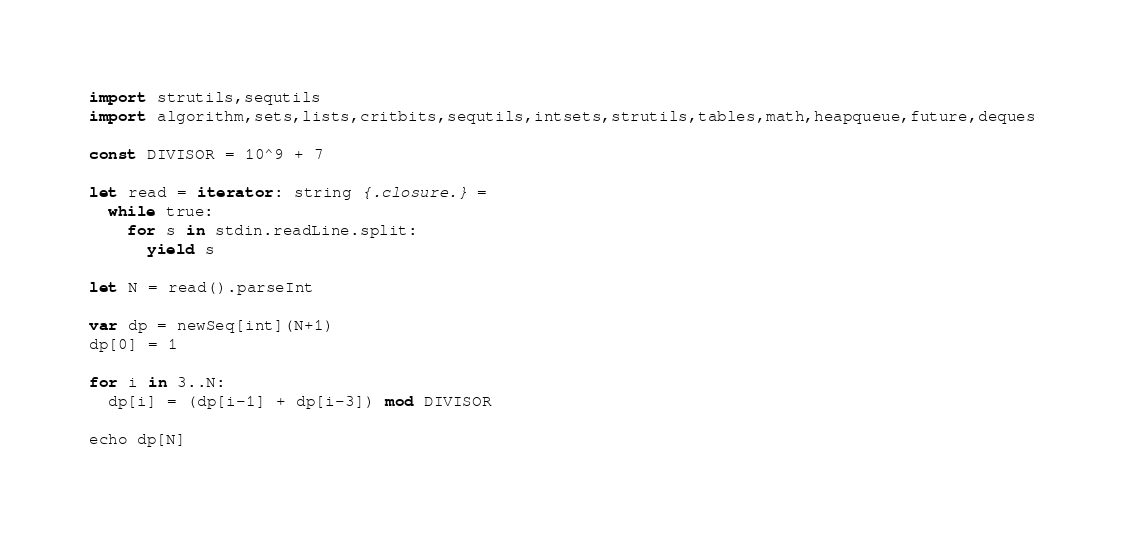<code> <loc_0><loc_0><loc_500><loc_500><_Nim_>import strutils,sequtils
import algorithm,sets,lists,critbits,sequtils,intsets,strutils,tables,math,heapqueue,future,deques

const DIVISOR = 10^9 + 7

let read = iterator: string {.closure.} =
  while true:
    for s in stdin.readLine.split:
      yield s

let N = read().parseInt

var dp = newSeq[int](N+1)
dp[0] = 1

for i in 3..N:
  dp[i] = (dp[i-1] + dp[i-3]) mod DIVISOR

echo dp[N]
</code> 